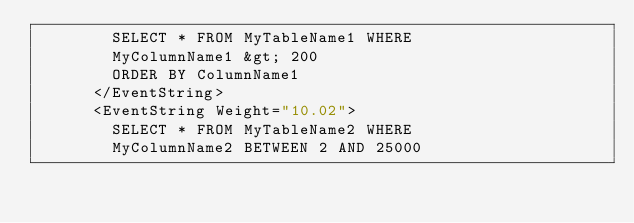Convert code to text. <code><loc_0><loc_0><loc_500><loc_500><_XML_>        SELECT * FROM MyTableName1 WHERE
        MyColumnName1 &gt; 200
        ORDER BY ColumnName1
      </EventString>
      <EventString Weight="10.02">
        SELECT * FROM MyTableName2 WHERE
        MyColumnName2 BETWEEN 2 AND 25000</code> 